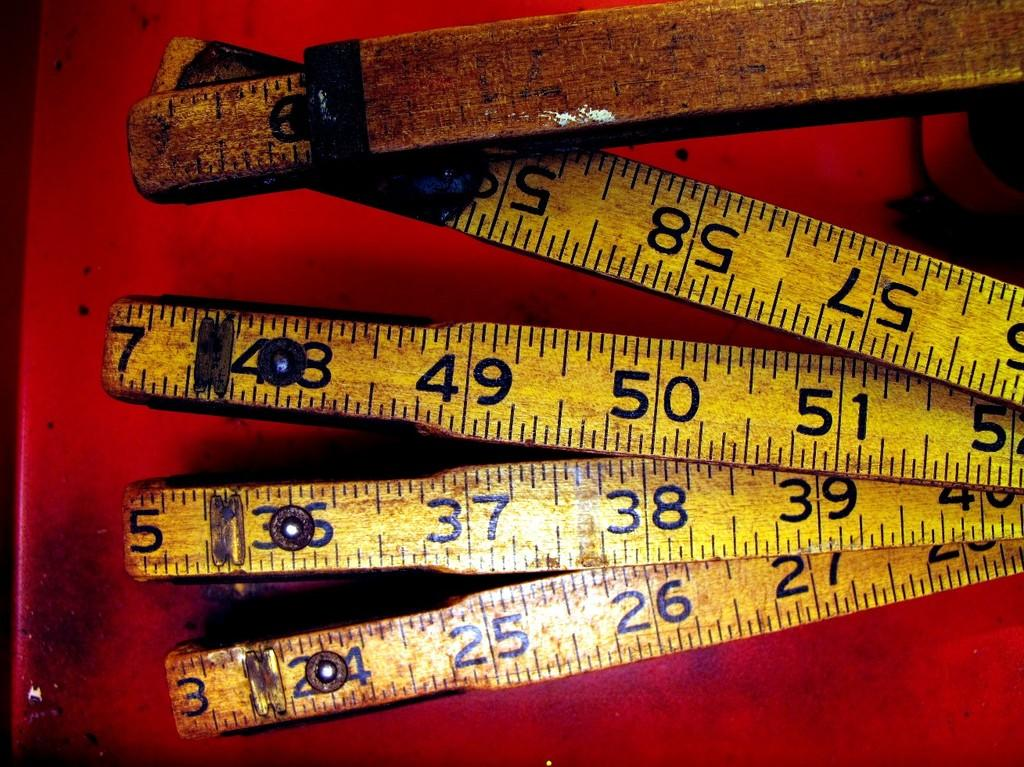<image>
Offer a succinct explanation of the picture presented. A tarnished folding ruler features numbers that go up to 57, 58, and 59. 